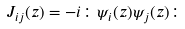<formula> <loc_0><loc_0><loc_500><loc_500>J _ { i j } ( z ) = - i \colon \psi _ { i } ( z ) \psi _ { j } ( z ) \colon</formula> 